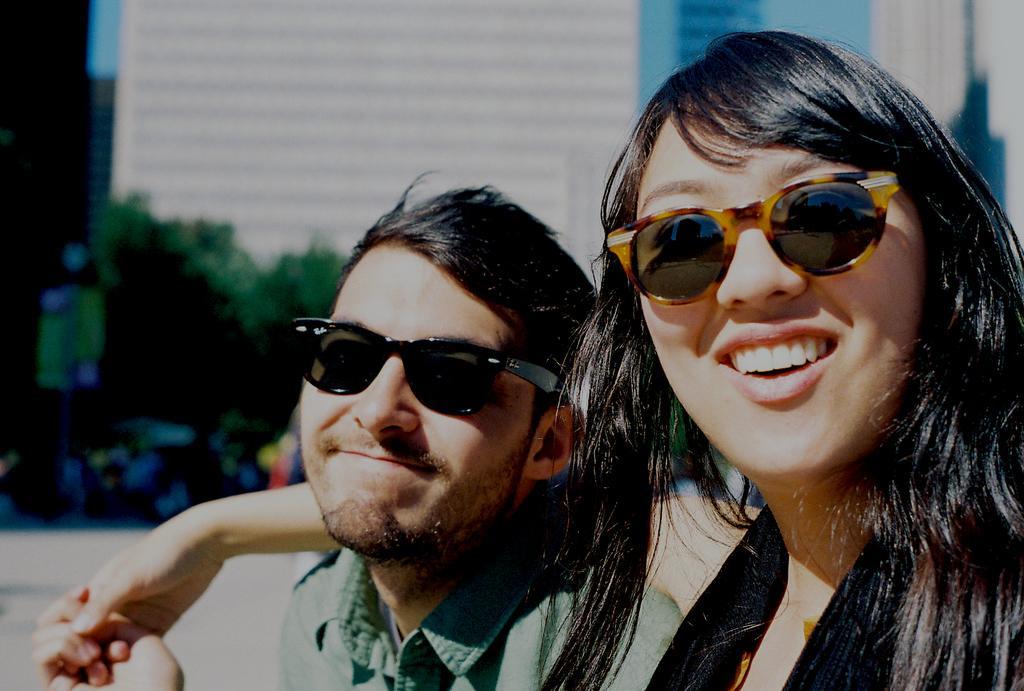How would you summarize this image in a sentence or two? In front of the picture, we see the woman in the black dress is sitting beside the man who is wearing a green shirt. She is trying to put her hand on the shoulders of the man. Both of them are wearing goggles. They are smiling. In the background, we see trees and buildings. It is blurred in the background. This picture is clicked outside the city and it is a sunny day. 